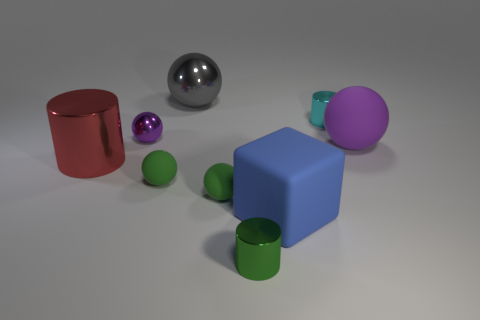There is a small cyan shiny object; does it have the same shape as the purple object behind the purple rubber ball?
Provide a succinct answer. No. What color is the large metallic thing behind the small shiny cylinder behind the small rubber thing that is to the right of the gray metal sphere?
Make the answer very short. Gray. Are there any small cyan shiny cylinders in front of the block?
Your answer should be very brief. No. The object that is the same color as the large matte ball is what size?
Your response must be concise. Small. Is there a blue cube made of the same material as the big red cylinder?
Your response must be concise. No. The small shiny sphere is what color?
Make the answer very short. Purple. Is the shape of the big matte object in front of the big red cylinder the same as  the large purple rubber object?
Provide a succinct answer. No. There is a big shiny object that is behind the purple object behind the purple thing to the right of the large blue object; what is its shape?
Your response must be concise. Sphere. What material is the purple sphere to the right of the small purple metallic object?
Your response must be concise. Rubber. What color is the ball that is the same size as the gray metal object?
Provide a succinct answer. Purple. 